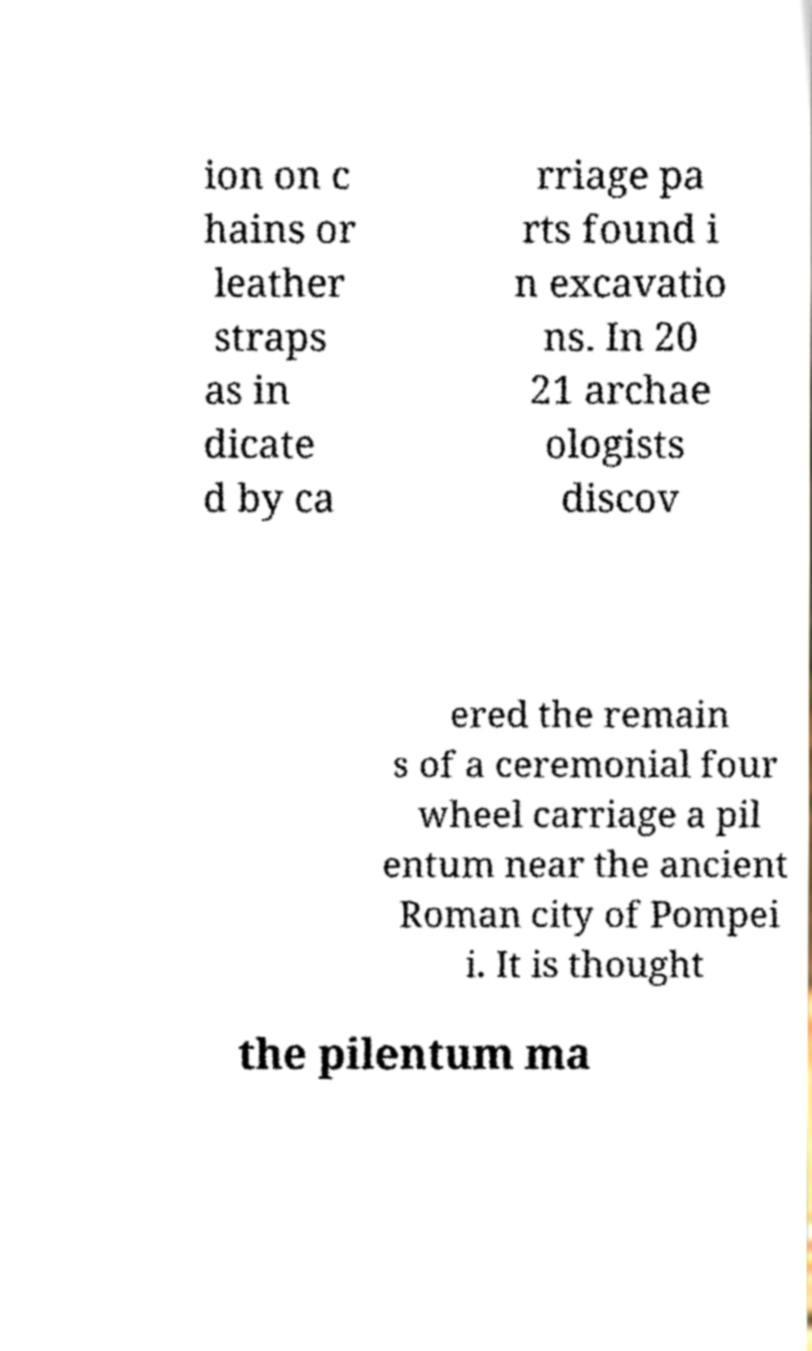Please read and relay the text visible in this image. What does it say? ion on c hains or leather straps as in dicate d by ca rriage pa rts found i n excavatio ns. In 20 21 archae ologists discov ered the remain s of a ceremonial four wheel carriage a pil entum near the ancient Roman city of Pompei i. It is thought the pilentum ma 